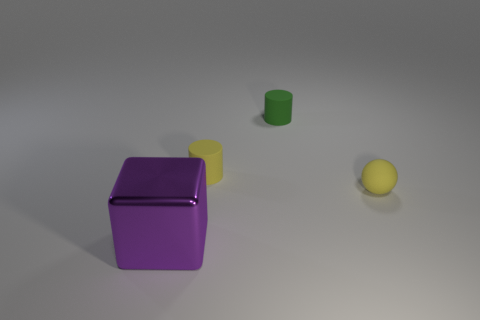There is a yellow thing that is behind the yellow ball; does it have the same size as the tiny green matte cylinder? After examining the image closely, it appears that the yellow object, which seems to be a flat square panel behind the yellow ball, does not have the same size as the tiny green matte cylinder. The yellow panel is larger, both in its length and width, compared to the dimensions of the green cylinder. 